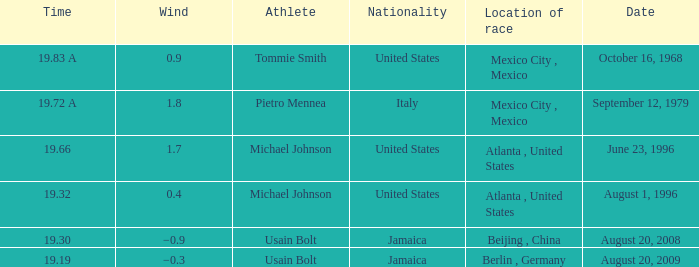7 and hailing from the united states? Michael Johnson. Could you help me parse every detail presented in this table? {'header': ['Time', 'Wind', 'Athlete', 'Nationality', 'Location of race', 'Date'], 'rows': [['19.83 A', '0.9', 'Tommie Smith', 'United States', 'Mexico City , Mexico', 'October 16, 1968'], ['19.72 A', '1.8', 'Pietro Mennea', 'Italy', 'Mexico City , Mexico', 'September 12, 1979'], ['19.66', '1.7', 'Michael Johnson', 'United States', 'Atlanta , United States', 'June 23, 1996'], ['19.32', '0.4', 'Michael Johnson', 'United States', 'Atlanta , United States', 'August 1, 1996'], ['19.30', '−0.9', 'Usain Bolt', 'Jamaica', 'Beijing , China', 'August 20, 2008'], ['19.19', '−0.3', 'Usain Bolt', 'Jamaica', 'Berlin , Germany', 'August 20, 2009']]} 